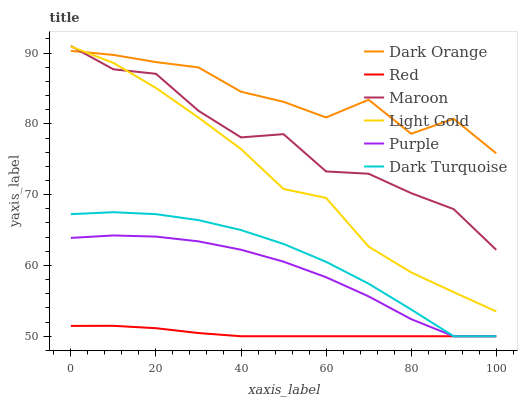Does Red have the minimum area under the curve?
Answer yes or no. Yes. Does Dark Orange have the maximum area under the curve?
Answer yes or no. Yes. Does Purple have the minimum area under the curve?
Answer yes or no. No. Does Purple have the maximum area under the curve?
Answer yes or no. No. Is Red the smoothest?
Answer yes or no. Yes. Is Dark Orange the roughest?
Answer yes or no. Yes. Is Purple the smoothest?
Answer yes or no. No. Is Purple the roughest?
Answer yes or no. No. Does Purple have the lowest value?
Answer yes or no. Yes. Does Maroon have the lowest value?
Answer yes or no. No. Does Maroon have the highest value?
Answer yes or no. Yes. Does Purple have the highest value?
Answer yes or no. No. Is Purple less than Light Gold?
Answer yes or no. Yes. Is Maroon greater than Purple?
Answer yes or no. Yes. Does Light Gold intersect Maroon?
Answer yes or no. Yes. Is Light Gold less than Maroon?
Answer yes or no. No. Is Light Gold greater than Maroon?
Answer yes or no. No. Does Purple intersect Light Gold?
Answer yes or no. No. 